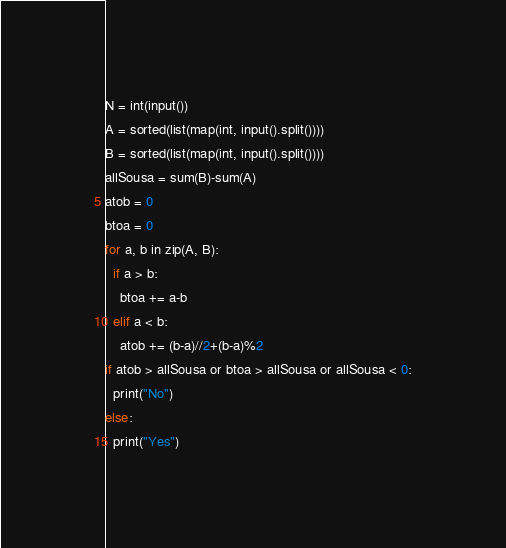<code> <loc_0><loc_0><loc_500><loc_500><_Python_>N = int(input())
A = sorted(list(map(int, input().split())))
B = sorted(list(map(int, input().split())))
allSousa = sum(B)-sum(A)
atob = 0
btoa = 0
for a, b in zip(A, B):
  if a > b:
    btoa += a-b
  elif a < b:
    atob += (b-a)//2+(b-a)%2
if atob > allSousa or btoa > allSousa or allSousa < 0:
  print("No")
else:
  print("Yes")
</code> 